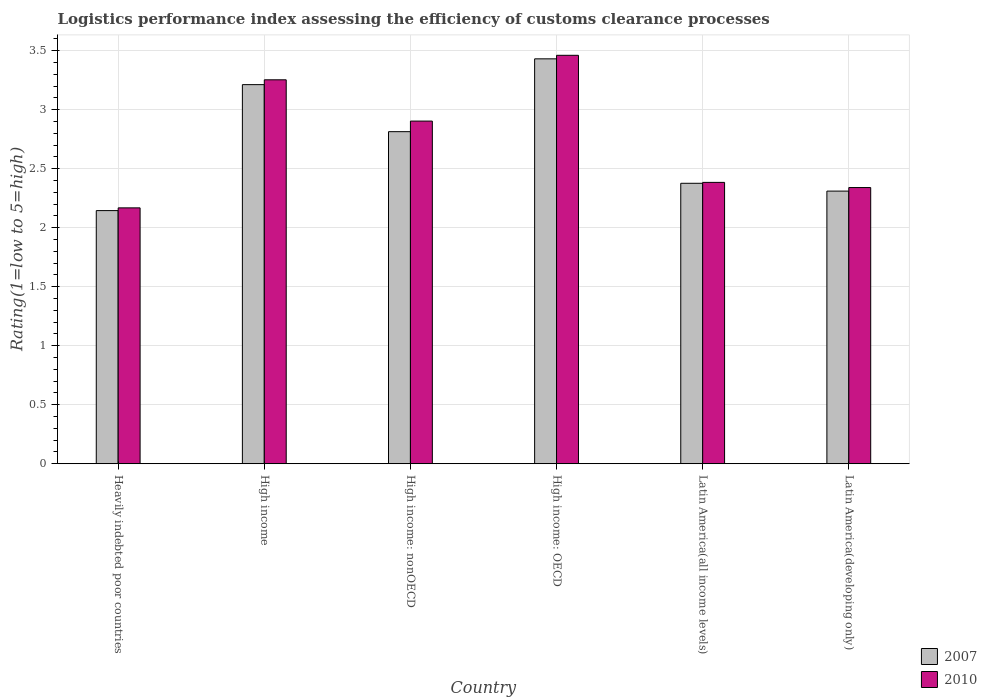Are the number of bars per tick equal to the number of legend labels?
Keep it short and to the point. Yes. Are the number of bars on each tick of the X-axis equal?
Offer a very short reply. Yes. How many bars are there on the 1st tick from the left?
Keep it short and to the point. 2. What is the label of the 4th group of bars from the left?
Provide a short and direct response. High income: OECD. In how many cases, is the number of bars for a given country not equal to the number of legend labels?
Offer a terse response. 0. What is the Logistic performance index in 2010 in Latin America(all income levels)?
Offer a terse response. 2.38. Across all countries, what is the maximum Logistic performance index in 2010?
Keep it short and to the point. 3.46. Across all countries, what is the minimum Logistic performance index in 2010?
Your answer should be compact. 2.17. In which country was the Logistic performance index in 2007 maximum?
Make the answer very short. High income: OECD. In which country was the Logistic performance index in 2007 minimum?
Ensure brevity in your answer.  Heavily indebted poor countries. What is the total Logistic performance index in 2007 in the graph?
Your answer should be very brief. 16.29. What is the difference between the Logistic performance index in 2010 in Heavily indebted poor countries and that in High income: OECD?
Provide a succinct answer. -1.29. What is the difference between the Logistic performance index in 2010 in Latin America(all income levels) and the Logistic performance index in 2007 in High income: nonOECD?
Your response must be concise. -0.43. What is the average Logistic performance index in 2010 per country?
Provide a succinct answer. 2.75. What is the difference between the Logistic performance index of/in 2007 and Logistic performance index of/in 2010 in Latin America(developing only)?
Your response must be concise. -0.03. What is the ratio of the Logistic performance index in 2010 in High income: nonOECD to that in Latin America(developing only)?
Provide a succinct answer. 1.24. Is the Logistic performance index in 2007 in Latin America(all income levels) less than that in Latin America(developing only)?
Offer a terse response. No. Is the difference between the Logistic performance index in 2007 in High income: OECD and High income: nonOECD greater than the difference between the Logistic performance index in 2010 in High income: OECD and High income: nonOECD?
Your response must be concise. Yes. What is the difference between the highest and the second highest Logistic performance index in 2007?
Your answer should be very brief. 0.4. What is the difference between the highest and the lowest Logistic performance index in 2010?
Provide a short and direct response. 1.29. What does the 2nd bar from the right in High income: nonOECD represents?
Ensure brevity in your answer.  2007. How many bars are there?
Give a very brief answer. 12. How many countries are there in the graph?
Keep it short and to the point. 6. Does the graph contain any zero values?
Your answer should be very brief. No. Does the graph contain grids?
Your response must be concise. Yes. Where does the legend appear in the graph?
Your answer should be very brief. Bottom right. How are the legend labels stacked?
Offer a terse response. Vertical. What is the title of the graph?
Ensure brevity in your answer.  Logistics performance index assessing the efficiency of customs clearance processes. Does "1965" appear as one of the legend labels in the graph?
Give a very brief answer. No. What is the label or title of the X-axis?
Offer a terse response. Country. What is the label or title of the Y-axis?
Provide a succinct answer. Rating(1=low to 5=high). What is the Rating(1=low to 5=high) of 2007 in Heavily indebted poor countries?
Offer a terse response. 2.14. What is the Rating(1=low to 5=high) in 2010 in Heavily indebted poor countries?
Ensure brevity in your answer.  2.17. What is the Rating(1=low to 5=high) of 2007 in High income?
Your answer should be compact. 3.21. What is the Rating(1=low to 5=high) of 2010 in High income?
Your answer should be very brief. 3.25. What is the Rating(1=low to 5=high) of 2007 in High income: nonOECD?
Keep it short and to the point. 2.81. What is the Rating(1=low to 5=high) in 2010 in High income: nonOECD?
Offer a terse response. 2.9. What is the Rating(1=low to 5=high) of 2007 in High income: OECD?
Your answer should be compact. 3.43. What is the Rating(1=low to 5=high) in 2010 in High income: OECD?
Ensure brevity in your answer.  3.46. What is the Rating(1=low to 5=high) in 2007 in Latin America(all income levels)?
Offer a terse response. 2.38. What is the Rating(1=low to 5=high) in 2010 in Latin America(all income levels)?
Your response must be concise. 2.38. What is the Rating(1=low to 5=high) in 2007 in Latin America(developing only)?
Offer a terse response. 2.31. What is the Rating(1=low to 5=high) of 2010 in Latin America(developing only)?
Provide a succinct answer. 2.34. Across all countries, what is the maximum Rating(1=low to 5=high) of 2007?
Ensure brevity in your answer.  3.43. Across all countries, what is the maximum Rating(1=low to 5=high) in 2010?
Your answer should be very brief. 3.46. Across all countries, what is the minimum Rating(1=low to 5=high) in 2007?
Offer a very short reply. 2.14. Across all countries, what is the minimum Rating(1=low to 5=high) in 2010?
Make the answer very short. 2.17. What is the total Rating(1=low to 5=high) of 2007 in the graph?
Your response must be concise. 16.29. What is the total Rating(1=low to 5=high) in 2010 in the graph?
Give a very brief answer. 16.51. What is the difference between the Rating(1=low to 5=high) in 2007 in Heavily indebted poor countries and that in High income?
Offer a terse response. -1.07. What is the difference between the Rating(1=low to 5=high) of 2010 in Heavily indebted poor countries and that in High income?
Your response must be concise. -1.08. What is the difference between the Rating(1=low to 5=high) in 2007 in Heavily indebted poor countries and that in High income: nonOECD?
Your response must be concise. -0.67. What is the difference between the Rating(1=low to 5=high) in 2010 in Heavily indebted poor countries and that in High income: nonOECD?
Provide a short and direct response. -0.74. What is the difference between the Rating(1=low to 5=high) of 2007 in Heavily indebted poor countries and that in High income: OECD?
Your answer should be very brief. -1.29. What is the difference between the Rating(1=low to 5=high) in 2010 in Heavily indebted poor countries and that in High income: OECD?
Ensure brevity in your answer.  -1.29. What is the difference between the Rating(1=low to 5=high) in 2007 in Heavily indebted poor countries and that in Latin America(all income levels)?
Offer a terse response. -0.23. What is the difference between the Rating(1=low to 5=high) in 2010 in Heavily indebted poor countries and that in Latin America(all income levels)?
Provide a short and direct response. -0.22. What is the difference between the Rating(1=low to 5=high) in 2007 in Heavily indebted poor countries and that in Latin America(developing only)?
Offer a very short reply. -0.17. What is the difference between the Rating(1=low to 5=high) in 2010 in Heavily indebted poor countries and that in Latin America(developing only)?
Offer a terse response. -0.17. What is the difference between the Rating(1=low to 5=high) in 2007 in High income and that in High income: nonOECD?
Provide a succinct answer. 0.4. What is the difference between the Rating(1=low to 5=high) of 2010 in High income and that in High income: nonOECD?
Make the answer very short. 0.35. What is the difference between the Rating(1=low to 5=high) of 2007 in High income and that in High income: OECD?
Your answer should be compact. -0.22. What is the difference between the Rating(1=low to 5=high) of 2010 in High income and that in High income: OECD?
Ensure brevity in your answer.  -0.21. What is the difference between the Rating(1=low to 5=high) in 2007 in High income and that in Latin America(all income levels)?
Ensure brevity in your answer.  0.84. What is the difference between the Rating(1=low to 5=high) in 2010 in High income and that in Latin America(all income levels)?
Make the answer very short. 0.87. What is the difference between the Rating(1=low to 5=high) of 2007 in High income and that in Latin America(developing only)?
Provide a succinct answer. 0.9. What is the difference between the Rating(1=low to 5=high) in 2010 in High income and that in Latin America(developing only)?
Your answer should be very brief. 0.91. What is the difference between the Rating(1=low to 5=high) in 2007 in High income: nonOECD and that in High income: OECD?
Keep it short and to the point. -0.62. What is the difference between the Rating(1=low to 5=high) in 2010 in High income: nonOECD and that in High income: OECD?
Your answer should be very brief. -0.56. What is the difference between the Rating(1=low to 5=high) in 2007 in High income: nonOECD and that in Latin America(all income levels)?
Your answer should be compact. 0.44. What is the difference between the Rating(1=low to 5=high) in 2010 in High income: nonOECD and that in Latin America(all income levels)?
Your response must be concise. 0.52. What is the difference between the Rating(1=low to 5=high) of 2007 in High income: nonOECD and that in Latin America(developing only)?
Make the answer very short. 0.5. What is the difference between the Rating(1=low to 5=high) of 2010 in High income: nonOECD and that in Latin America(developing only)?
Keep it short and to the point. 0.56. What is the difference between the Rating(1=low to 5=high) of 2007 in High income: OECD and that in Latin America(all income levels)?
Provide a short and direct response. 1.05. What is the difference between the Rating(1=low to 5=high) in 2010 in High income: OECD and that in Latin America(all income levels)?
Offer a very short reply. 1.08. What is the difference between the Rating(1=low to 5=high) in 2007 in High income: OECD and that in Latin America(developing only)?
Keep it short and to the point. 1.12. What is the difference between the Rating(1=low to 5=high) of 2010 in High income: OECD and that in Latin America(developing only)?
Your answer should be very brief. 1.12. What is the difference between the Rating(1=low to 5=high) of 2007 in Latin America(all income levels) and that in Latin America(developing only)?
Give a very brief answer. 0.07. What is the difference between the Rating(1=low to 5=high) of 2010 in Latin America(all income levels) and that in Latin America(developing only)?
Ensure brevity in your answer.  0.04. What is the difference between the Rating(1=low to 5=high) in 2007 in Heavily indebted poor countries and the Rating(1=low to 5=high) in 2010 in High income?
Keep it short and to the point. -1.11. What is the difference between the Rating(1=low to 5=high) in 2007 in Heavily indebted poor countries and the Rating(1=low to 5=high) in 2010 in High income: nonOECD?
Your answer should be compact. -0.76. What is the difference between the Rating(1=low to 5=high) of 2007 in Heavily indebted poor countries and the Rating(1=low to 5=high) of 2010 in High income: OECD?
Provide a short and direct response. -1.32. What is the difference between the Rating(1=low to 5=high) of 2007 in Heavily indebted poor countries and the Rating(1=low to 5=high) of 2010 in Latin America(all income levels)?
Your answer should be very brief. -0.24. What is the difference between the Rating(1=low to 5=high) in 2007 in Heavily indebted poor countries and the Rating(1=low to 5=high) in 2010 in Latin America(developing only)?
Your answer should be very brief. -0.2. What is the difference between the Rating(1=low to 5=high) of 2007 in High income and the Rating(1=low to 5=high) of 2010 in High income: nonOECD?
Your answer should be very brief. 0.31. What is the difference between the Rating(1=low to 5=high) in 2007 in High income and the Rating(1=low to 5=high) in 2010 in High income: OECD?
Make the answer very short. -0.25. What is the difference between the Rating(1=low to 5=high) in 2007 in High income and the Rating(1=low to 5=high) in 2010 in Latin America(all income levels)?
Provide a short and direct response. 0.83. What is the difference between the Rating(1=low to 5=high) in 2007 in High income and the Rating(1=low to 5=high) in 2010 in Latin America(developing only)?
Your response must be concise. 0.87. What is the difference between the Rating(1=low to 5=high) of 2007 in High income: nonOECD and the Rating(1=low to 5=high) of 2010 in High income: OECD?
Offer a terse response. -0.65. What is the difference between the Rating(1=low to 5=high) of 2007 in High income: nonOECD and the Rating(1=low to 5=high) of 2010 in Latin America(all income levels)?
Provide a short and direct response. 0.43. What is the difference between the Rating(1=low to 5=high) in 2007 in High income: nonOECD and the Rating(1=low to 5=high) in 2010 in Latin America(developing only)?
Offer a very short reply. 0.47. What is the difference between the Rating(1=low to 5=high) of 2007 in High income: OECD and the Rating(1=low to 5=high) of 2010 in Latin America(all income levels)?
Make the answer very short. 1.05. What is the difference between the Rating(1=low to 5=high) in 2007 in High income: OECD and the Rating(1=low to 5=high) in 2010 in Latin America(developing only)?
Your response must be concise. 1.09. What is the difference between the Rating(1=low to 5=high) of 2007 in Latin America(all income levels) and the Rating(1=low to 5=high) of 2010 in Latin America(developing only)?
Give a very brief answer. 0.04. What is the average Rating(1=low to 5=high) of 2007 per country?
Provide a succinct answer. 2.71. What is the average Rating(1=low to 5=high) in 2010 per country?
Your answer should be compact. 2.75. What is the difference between the Rating(1=low to 5=high) of 2007 and Rating(1=low to 5=high) of 2010 in Heavily indebted poor countries?
Offer a very short reply. -0.02. What is the difference between the Rating(1=low to 5=high) in 2007 and Rating(1=low to 5=high) in 2010 in High income?
Your response must be concise. -0.04. What is the difference between the Rating(1=low to 5=high) of 2007 and Rating(1=low to 5=high) of 2010 in High income: nonOECD?
Offer a very short reply. -0.09. What is the difference between the Rating(1=low to 5=high) in 2007 and Rating(1=low to 5=high) in 2010 in High income: OECD?
Make the answer very short. -0.03. What is the difference between the Rating(1=low to 5=high) in 2007 and Rating(1=low to 5=high) in 2010 in Latin America(all income levels)?
Offer a terse response. -0.01. What is the difference between the Rating(1=low to 5=high) of 2007 and Rating(1=low to 5=high) of 2010 in Latin America(developing only)?
Make the answer very short. -0.03. What is the ratio of the Rating(1=low to 5=high) of 2007 in Heavily indebted poor countries to that in High income?
Give a very brief answer. 0.67. What is the ratio of the Rating(1=low to 5=high) in 2010 in Heavily indebted poor countries to that in High income?
Give a very brief answer. 0.67. What is the ratio of the Rating(1=low to 5=high) in 2007 in Heavily indebted poor countries to that in High income: nonOECD?
Give a very brief answer. 0.76. What is the ratio of the Rating(1=low to 5=high) in 2010 in Heavily indebted poor countries to that in High income: nonOECD?
Your response must be concise. 0.75. What is the ratio of the Rating(1=low to 5=high) in 2007 in Heavily indebted poor countries to that in High income: OECD?
Your response must be concise. 0.63. What is the ratio of the Rating(1=low to 5=high) of 2010 in Heavily indebted poor countries to that in High income: OECD?
Ensure brevity in your answer.  0.63. What is the ratio of the Rating(1=low to 5=high) in 2007 in Heavily indebted poor countries to that in Latin America(all income levels)?
Keep it short and to the point. 0.9. What is the ratio of the Rating(1=low to 5=high) of 2010 in Heavily indebted poor countries to that in Latin America(all income levels)?
Your answer should be compact. 0.91. What is the ratio of the Rating(1=low to 5=high) in 2007 in Heavily indebted poor countries to that in Latin America(developing only)?
Your answer should be very brief. 0.93. What is the ratio of the Rating(1=low to 5=high) in 2010 in Heavily indebted poor countries to that in Latin America(developing only)?
Offer a terse response. 0.93. What is the ratio of the Rating(1=low to 5=high) in 2007 in High income to that in High income: nonOECD?
Make the answer very short. 1.14. What is the ratio of the Rating(1=low to 5=high) of 2010 in High income to that in High income: nonOECD?
Keep it short and to the point. 1.12. What is the ratio of the Rating(1=low to 5=high) in 2007 in High income to that in High income: OECD?
Offer a terse response. 0.94. What is the ratio of the Rating(1=low to 5=high) in 2007 in High income to that in Latin America(all income levels)?
Give a very brief answer. 1.35. What is the ratio of the Rating(1=low to 5=high) in 2010 in High income to that in Latin America(all income levels)?
Your answer should be compact. 1.36. What is the ratio of the Rating(1=low to 5=high) in 2007 in High income to that in Latin America(developing only)?
Provide a succinct answer. 1.39. What is the ratio of the Rating(1=low to 5=high) in 2010 in High income to that in Latin America(developing only)?
Your answer should be very brief. 1.39. What is the ratio of the Rating(1=low to 5=high) of 2007 in High income: nonOECD to that in High income: OECD?
Offer a very short reply. 0.82. What is the ratio of the Rating(1=low to 5=high) in 2010 in High income: nonOECD to that in High income: OECD?
Your response must be concise. 0.84. What is the ratio of the Rating(1=low to 5=high) in 2007 in High income: nonOECD to that in Latin America(all income levels)?
Your response must be concise. 1.18. What is the ratio of the Rating(1=low to 5=high) of 2010 in High income: nonOECD to that in Latin America(all income levels)?
Keep it short and to the point. 1.22. What is the ratio of the Rating(1=low to 5=high) of 2007 in High income: nonOECD to that in Latin America(developing only)?
Provide a short and direct response. 1.22. What is the ratio of the Rating(1=low to 5=high) of 2010 in High income: nonOECD to that in Latin America(developing only)?
Offer a very short reply. 1.24. What is the ratio of the Rating(1=low to 5=high) of 2007 in High income: OECD to that in Latin America(all income levels)?
Provide a short and direct response. 1.44. What is the ratio of the Rating(1=low to 5=high) of 2010 in High income: OECD to that in Latin America(all income levels)?
Ensure brevity in your answer.  1.45. What is the ratio of the Rating(1=low to 5=high) in 2007 in High income: OECD to that in Latin America(developing only)?
Give a very brief answer. 1.49. What is the ratio of the Rating(1=low to 5=high) in 2010 in High income: OECD to that in Latin America(developing only)?
Ensure brevity in your answer.  1.48. What is the ratio of the Rating(1=low to 5=high) of 2007 in Latin America(all income levels) to that in Latin America(developing only)?
Make the answer very short. 1.03. What is the ratio of the Rating(1=low to 5=high) of 2010 in Latin America(all income levels) to that in Latin America(developing only)?
Your answer should be compact. 1.02. What is the difference between the highest and the second highest Rating(1=low to 5=high) of 2007?
Your answer should be compact. 0.22. What is the difference between the highest and the second highest Rating(1=low to 5=high) of 2010?
Provide a succinct answer. 0.21. What is the difference between the highest and the lowest Rating(1=low to 5=high) in 2007?
Your response must be concise. 1.29. What is the difference between the highest and the lowest Rating(1=low to 5=high) of 2010?
Your response must be concise. 1.29. 